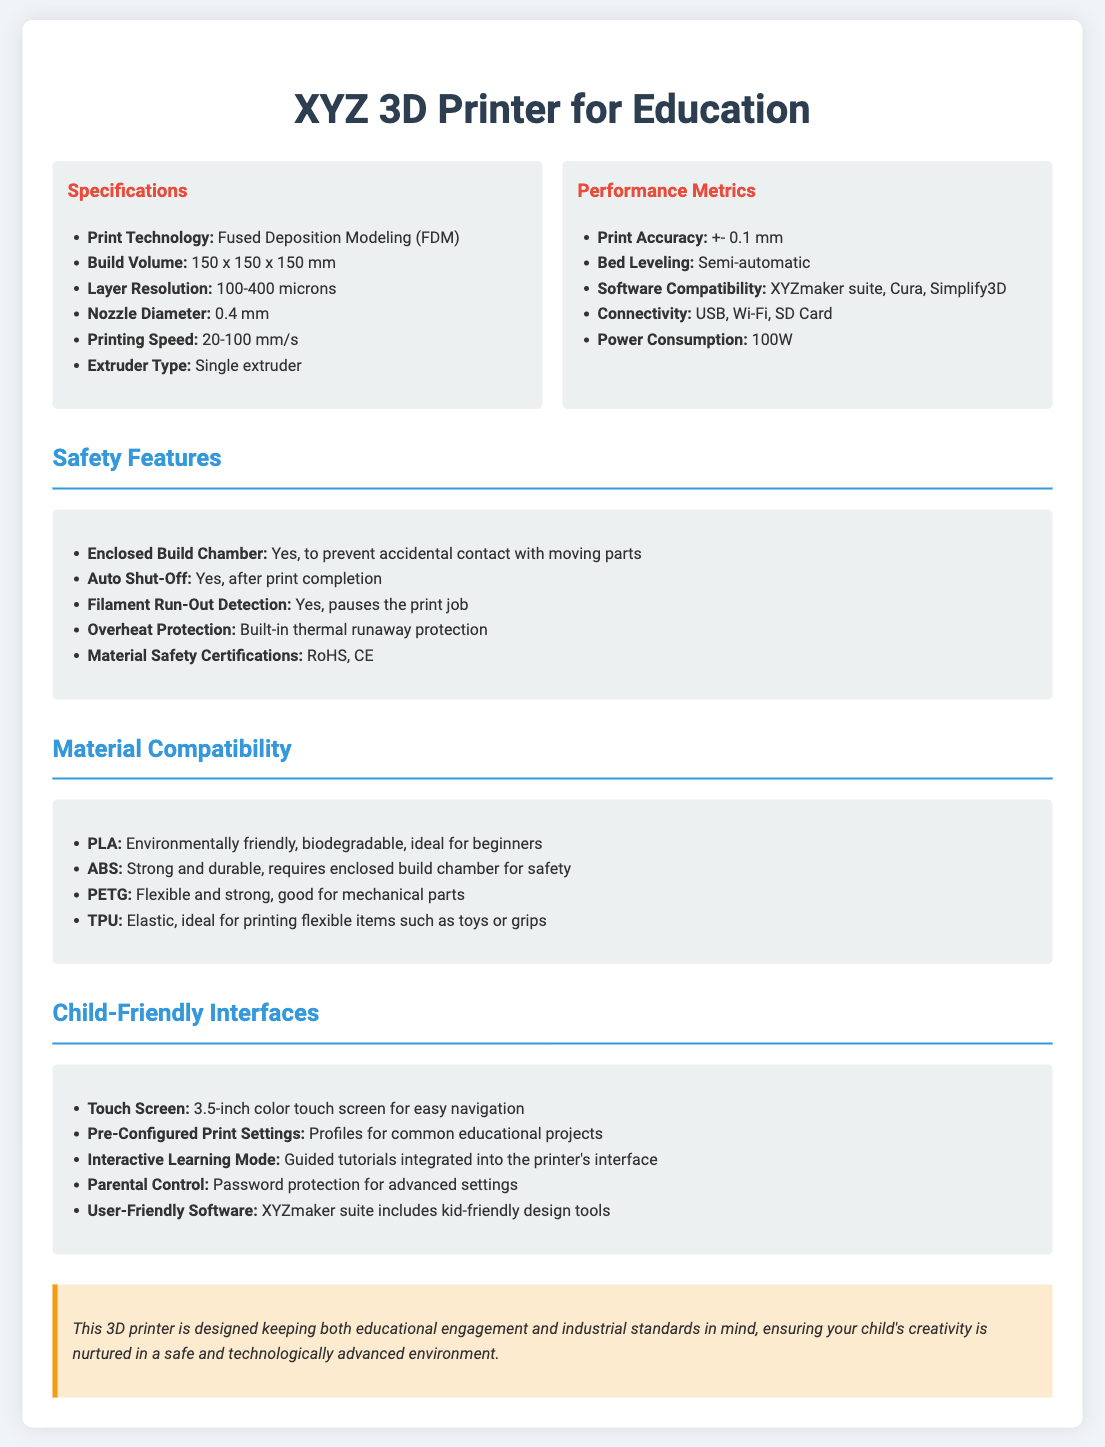What is the print technology used? The print technology is specified in the document under the specifications section as Fused Deposition Modeling (FDM).
Answer: Fused Deposition Modeling (FDM) What is the build volume of the printer? The build volume is mentioned as dimensions in the specifications section, specifically as 150 x 150 x 150 mm.
Answer: 150 x 150 x 150 mm What safety feature prevents accidents during printing? The document states that the enclosed build chamber serves to prevent accidental contact with moving parts, found under safety features.
Answer: Enclosed Build Chamber What material is described as environmentally friendly and biodegradable? PLA is identified in the material compatibility section as being environmentally friendly and biodegradable.
Answer: PLA How many microns can the printer layer resolution achieve? The layer resolution is provided in the specifications section ranging between 100 to 400 microns.
Answer: 100-400 microns What type of display does the printer have for user interaction? The child-friendly interfaces section mentions a 3.5-inch color touch screen for easy navigation.
Answer: 3.5-inch color touch screen Which software is compatible with the printer? The software compatibility section indicates that the printer works with XYZmaker suite, Cura, and Simplify3D.
Answer: XYZmaker suite, Cura, Simplify3D What feature allows the printer to pause if the filament runs out? The document includes filament run-out detection in the safety features section that pauses the print job when filament is depleted.
Answer: Filament Run-Out Detection What is the power consumption of the printer? The performance metrics section specifies that the power consumption of the printer is 100W.
Answer: 100W 